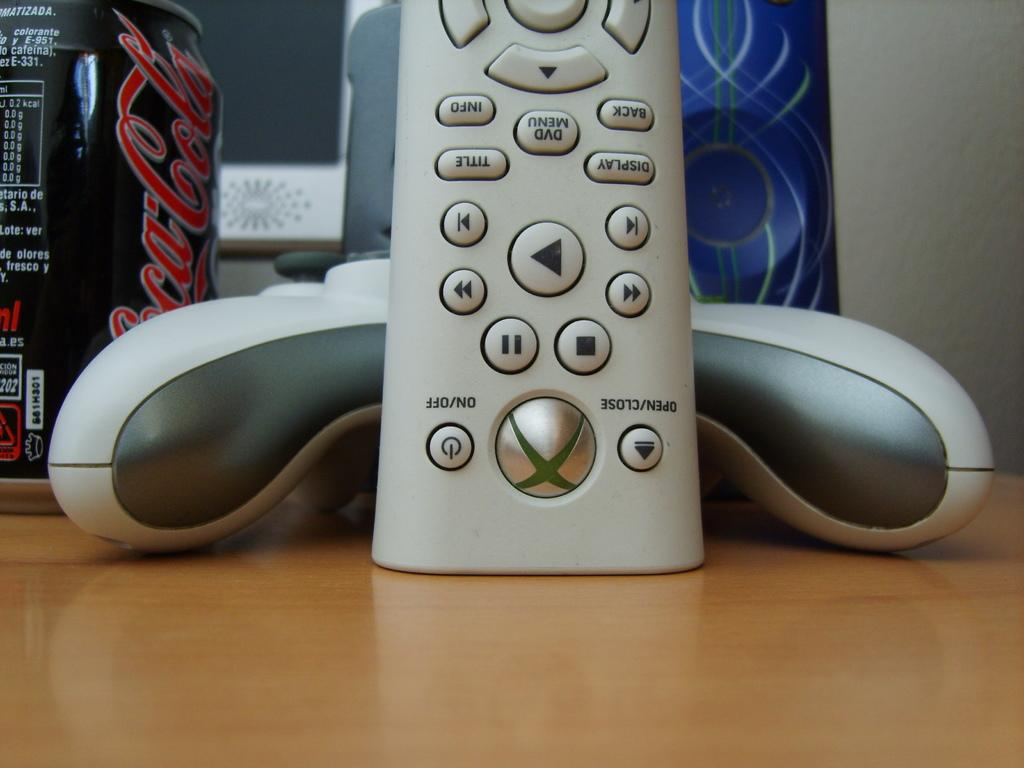<image>
Present a compact description of the photo's key features. An Xbox 360 remote, controller and a Coca-Cola can are sitting on a wooden desk. 